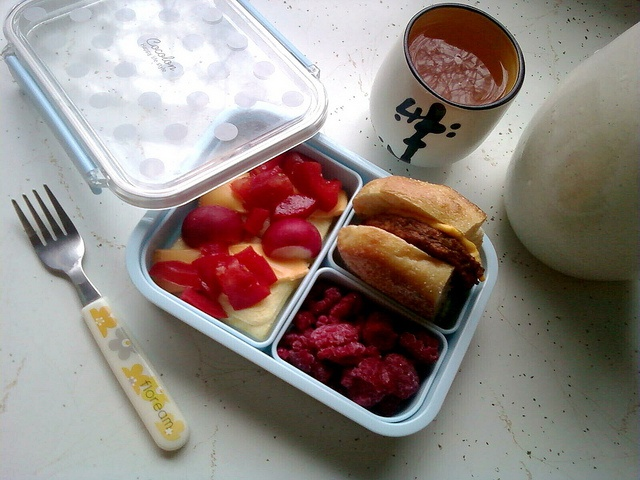Describe the objects in this image and their specific colors. I can see dining table in darkgray, lightgray, gray, black, and maroon tones, cup in lightgray, maroon, gray, and darkgray tones, sandwich in lightgray, maroon, black, brown, and tan tones, and fork in lightgray, darkgray, tan, gray, and black tones in this image. 